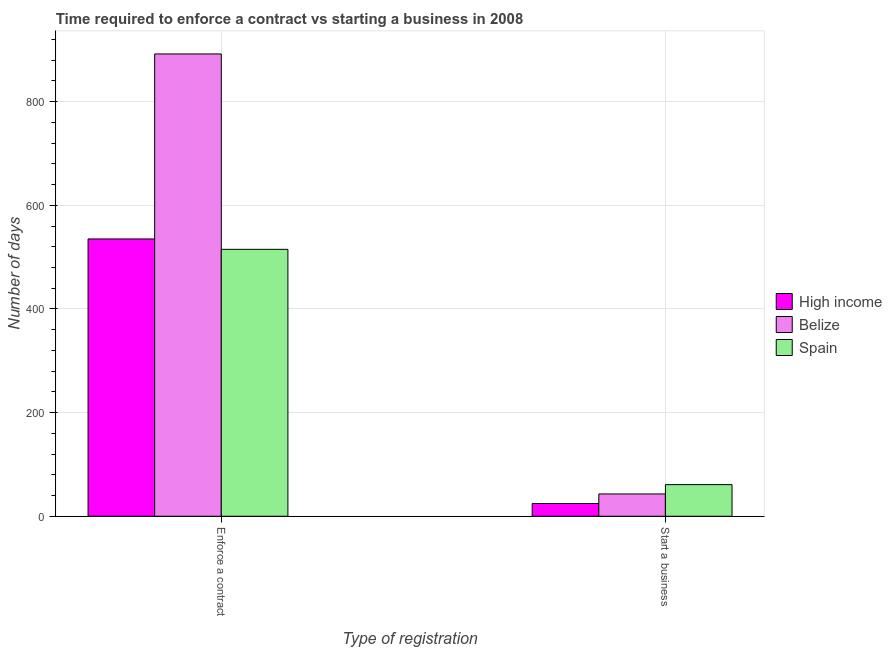Are the number of bars per tick equal to the number of legend labels?
Ensure brevity in your answer.  Yes. What is the label of the 1st group of bars from the left?
Offer a very short reply. Enforce a contract. Across all countries, what is the minimum number of days to start a business?
Offer a very short reply. 24.57. In which country was the number of days to start a business maximum?
Make the answer very short. Spain. What is the total number of days to start a business in the graph?
Give a very brief answer. 128.57. What is the difference between the number of days to start a business in Spain and that in Belize?
Provide a succinct answer. 18. What is the difference between the number of days to enforece a contract in High income and the number of days to start a business in Belize?
Ensure brevity in your answer.  492.04. What is the average number of days to enforece a contract per country?
Offer a terse response. 647.35. What is the difference between the number of days to enforece a contract and number of days to start a business in Spain?
Your response must be concise. 454. What is the ratio of the number of days to enforece a contract in Belize to that in Spain?
Keep it short and to the point. 1.73. What does the 2nd bar from the left in Enforce a contract represents?
Your answer should be very brief. Belize. How many bars are there?
Keep it short and to the point. 6. Are all the bars in the graph horizontal?
Offer a very short reply. No. How many countries are there in the graph?
Your answer should be compact. 3. Are the values on the major ticks of Y-axis written in scientific E-notation?
Your answer should be compact. No. Where does the legend appear in the graph?
Provide a short and direct response. Center right. How many legend labels are there?
Provide a short and direct response. 3. What is the title of the graph?
Give a very brief answer. Time required to enforce a contract vs starting a business in 2008. Does "Fiji" appear as one of the legend labels in the graph?
Give a very brief answer. No. What is the label or title of the X-axis?
Give a very brief answer. Type of registration. What is the label or title of the Y-axis?
Provide a short and direct response. Number of days. What is the Number of days of High income in Enforce a contract?
Give a very brief answer. 535.04. What is the Number of days in Belize in Enforce a contract?
Your answer should be compact. 892. What is the Number of days of Spain in Enforce a contract?
Your answer should be very brief. 515. What is the Number of days of High income in Start a business?
Keep it short and to the point. 24.57. What is the Number of days of Spain in Start a business?
Your answer should be compact. 61. Across all Type of registration, what is the maximum Number of days in High income?
Make the answer very short. 535.04. Across all Type of registration, what is the maximum Number of days of Belize?
Make the answer very short. 892. Across all Type of registration, what is the maximum Number of days of Spain?
Ensure brevity in your answer.  515. Across all Type of registration, what is the minimum Number of days in High income?
Provide a succinct answer. 24.57. Across all Type of registration, what is the minimum Number of days of Belize?
Keep it short and to the point. 43. What is the total Number of days of High income in the graph?
Offer a very short reply. 559.61. What is the total Number of days in Belize in the graph?
Offer a very short reply. 935. What is the total Number of days of Spain in the graph?
Your answer should be very brief. 576. What is the difference between the Number of days of High income in Enforce a contract and that in Start a business?
Your answer should be very brief. 510.46. What is the difference between the Number of days in Belize in Enforce a contract and that in Start a business?
Give a very brief answer. 849. What is the difference between the Number of days of Spain in Enforce a contract and that in Start a business?
Ensure brevity in your answer.  454. What is the difference between the Number of days in High income in Enforce a contract and the Number of days in Belize in Start a business?
Offer a very short reply. 492.04. What is the difference between the Number of days in High income in Enforce a contract and the Number of days in Spain in Start a business?
Offer a terse response. 474.04. What is the difference between the Number of days in Belize in Enforce a contract and the Number of days in Spain in Start a business?
Your answer should be very brief. 831. What is the average Number of days in High income per Type of registration?
Your answer should be compact. 279.81. What is the average Number of days in Belize per Type of registration?
Provide a short and direct response. 467.5. What is the average Number of days of Spain per Type of registration?
Give a very brief answer. 288. What is the difference between the Number of days in High income and Number of days in Belize in Enforce a contract?
Make the answer very short. -356.96. What is the difference between the Number of days of High income and Number of days of Spain in Enforce a contract?
Make the answer very short. 20.04. What is the difference between the Number of days in Belize and Number of days in Spain in Enforce a contract?
Provide a short and direct response. 377. What is the difference between the Number of days of High income and Number of days of Belize in Start a business?
Provide a succinct answer. -18.43. What is the difference between the Number of days of High income and Number of days of Spain in Start a business?
Offer a very short reply. -36.43. What is the difference between the Number of days in Belize and Number of days in Spain in Start a business?
Offer a terse response. -18. What is the ratio of the Number of days of High income in Enforce a contract to that in Start a business?
Keep it short and to the point. 21.77. What is the ratio of the Number of days in Belize in Enforce a contract to that in Start a business?
Offer a terse response. 20.74. What is the ratio of the Number of days in Spain in Enforce a contract to that in Start a business?
Keep it short and to the point. 8.44. What is the difference between the highest and the second highest Number of days in High income?
Your answer should be very brief. 510.46. What is the difference between the highest and the second highest Number of days in Belize?
Provide a short and direct response. 849. What is the difference between the highest and the second highest Number of days of Spain?
Your response must be concise. 454. What is the difference between the highest and the lowest Number of days in High income?
Ensure brevity in your answer.  510.46. What is the difference between the highest and the lowest Number of days of Belize?
Offer a very short reply. 849. What is the difference between the highest and the lowest Number of days of Spain?
Offer a terse response. 454. 